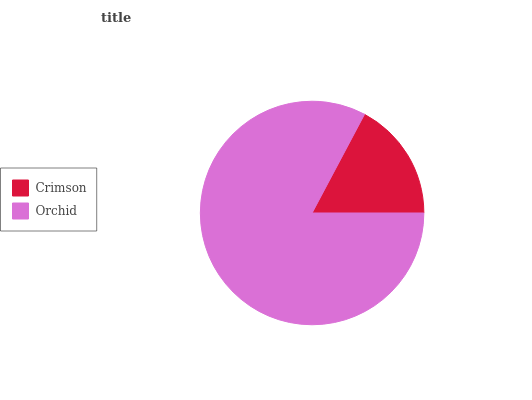Is Crimson the minimum?
Answer yes or no. Yes. Is Orchid the maximum?
Answer yes or no. Yes. Is Orchid the minimum?
Answer yes or no. No. Is Orchid greater than Crimson?
Answer yes or no. Yes. Is Crimson less than Orchid?
Answer yes or no. Yes. Is Crimson greater than Orchid?
Answer yes or no. No. Is Orchid less than Crimson?
Answer yes or no. No. Is Orchid the high median?
Answer yes or no. Yes. Is Crimson the low median?
Answer yes or no. Yes. Is Crimson the high median?
Answer yes or no. No. Is Orchid the low median?
Answer yes or no. No. 